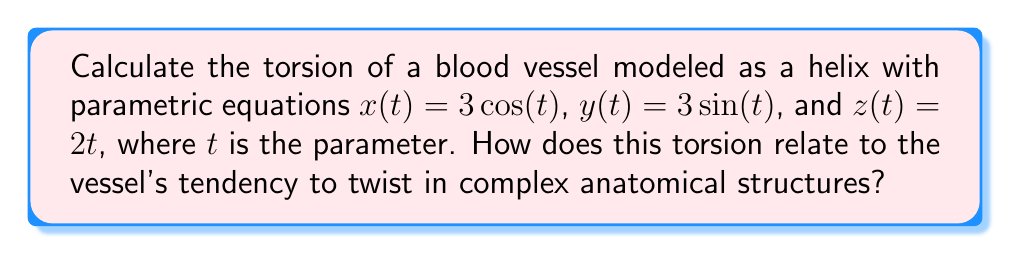Provide a solution to this math problem. To calculate the torsion of the blood vessel modeled as a helix, we'll follow these steps:

1) First, recall the formula for torsion ($\tau$):

   $$\tau = \frac{(\mathbf{r'} \times \mathbf{r''}) \cdot \mathbf{r'''}}{\|\mathbf{r'} \times \mathbf{r''}\|^2}$$

2) Calculate $\mathbf{r'}(t)$:
   $$\mathbf{r'}(t) = (-3\sin(t), 3\cos(t), 2)$$

3) Calculate $\mathbf{r''}(t)$:
   $$\mathbf{r''}(t) = (-3\cos(t), -3\sin(t), 0)$$

4) Calculate $\mathbf{r'''}(t)$:
   $$\mathbf{r'''}(t) = (3\sin(t), -3\cos(t), 0)$$

5) Calculate $\mathbf{r'} \times \mathbf{r''}$:
   $$\mathbf{r'} \times \mathbf{r''} = (6\sin(t), -6\cos(t), 9)$$

6) Calculate $(\mathbf{r'} \times \mathbf{r''}) \cdot \mathbf{r'''}$:
   $$(\mathbf{r'} \times \mathbf{r''}) \cdot \mathbf{r'''} = 18\sin^2(t) + 18\cos^2(t) = 18$$

7) Calculate $\|\mathbf{r'} \times \mathbf{r''}\|^2$:
   $$\|\mathbf{r'} \times \mathbf{r''}\|^2 = 36\sin^2(t) + 36\cos^2(t) + 81 = 117$$

8) Finally, calculate the torsion:
   $$\tau = \frac{18}{117} = \frac{2}{13}$$

The constant, non-zero torsion indicates that the blood vessel has a constant tendency to twist along its length. This is characteristic of helical structures and suggests that the vessel maintains a consistent spiral shape as it traverses complex anatomical structures. In biomechanics, this constant torsion could influence blood flow dynamics and the vessel's response to mechanical stresses in the body.
Answer: $\frac{2}{13}$ 